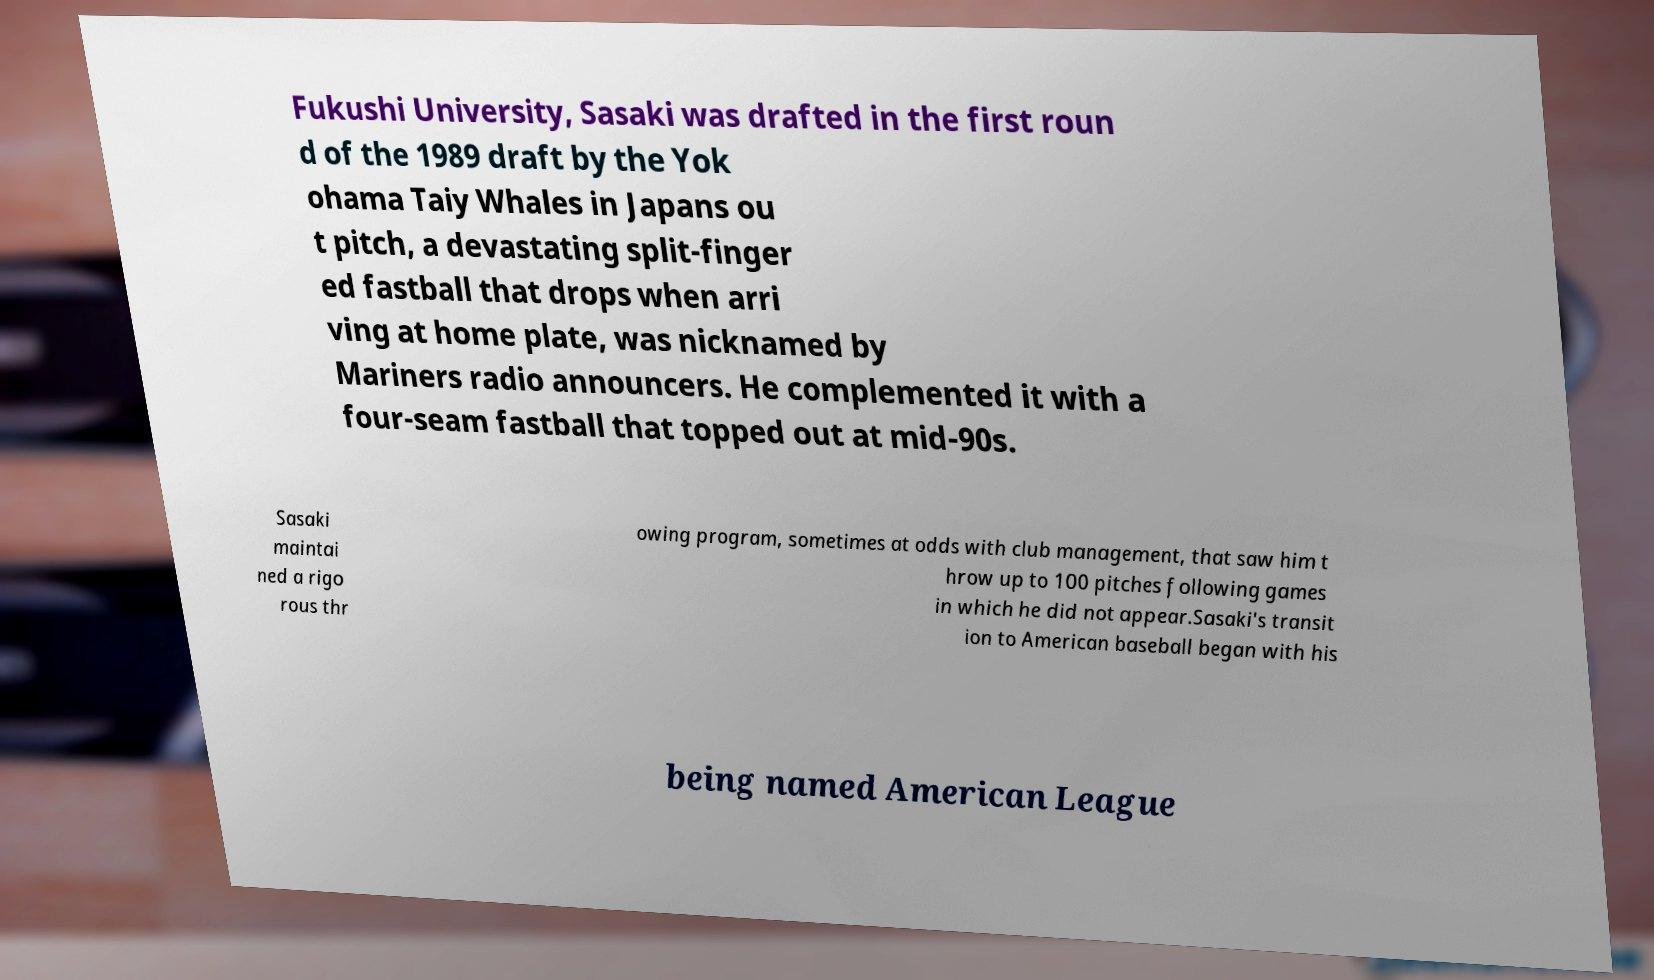There's text embedded in this image that I need extracted. Can you transcribe it verbatim? Fukushi University, Sasaki was drafted in the first roun d of the 1989 draft by the Yok ohama Taiy Whales in Japans ou t pitch, a devastating split-finger ed fastball that drops when arri ving at home plate, was nicknamed by Mariners radio announcers. He complemented it with a four-seam fastball that topped out at mid-90s. Sasaki maintai ned a rigo rous thr owing program, sometimes at odds with club management, that saw him t hrow up to 100 pitches following games in which he did not appear.Sasaki's transit ion to American baseball began with his being named American League 